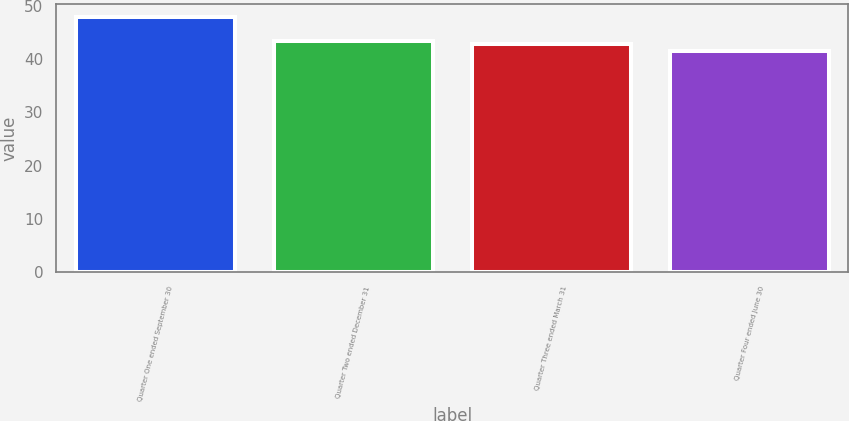<chart> <loc_0><loc_0><loc_500><loc_500><bar_chart><fcel>Quarter One ended September 30<fcel>Quarter Two ended December 31<fcel>Quarter Three ended March 31<fcel>Quarter Four ended June 30<nl><fcel>47.98<fcel>43.45<fcel>42.81<fcel>41.56<nl></chart> 